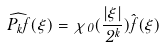Convert formula to latex. <formula><loc_0><loc_0><loc_500><loc_500>\widehat { P _ { k } f } ( \xi ) = \chi _ { 0 } ( \frac { | \xi | } { 2 ^ { k } } ) \hat { f } ( \xi )</formula> 